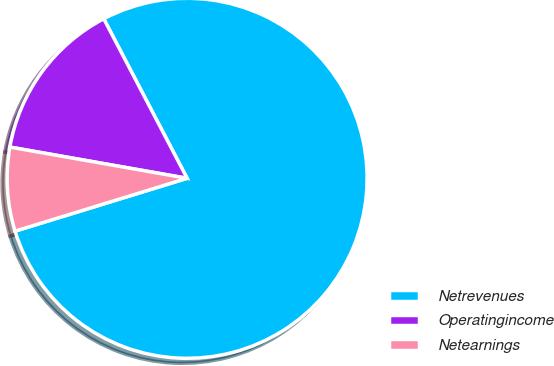Convert chart. <chart><loc_0><loc_0><loc_500><loc_500><pie_chart><fcel>Netrevenues<fcel>Operatingincome<fcel>Netearnings<nl><fcel>77.92%<fcel>14.56%<fcel>7.52%<nl></chart> 